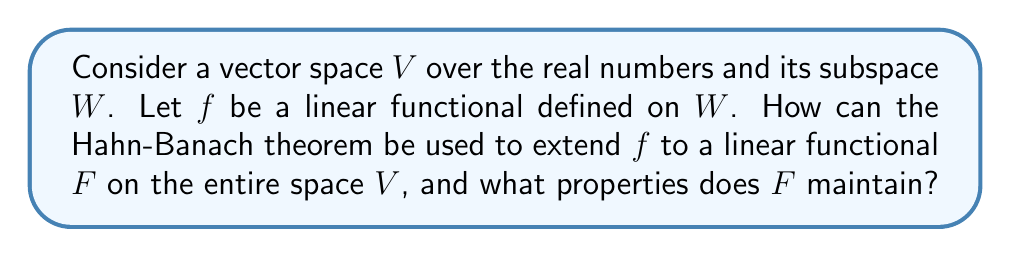Can you answer this question? To understand how the Hahn-Banach theorem applies in this situation, let's break it down step-by-step:

1) First, recall the Hahn-Banach theorem: Let $W$ be a subspace of a real vector space $V$, and let $f$ be a linear functional on $W$. If $p$ is a sublinear functional on $V$ such that $f(w) \leq p(w)$ for all $w \in W$, then there exists a linear functional $F$ on $V$ that extends $f$ (i.e., $F|_W = f$) and satisfies $F(v) \leq p(v)$ for all $v \in V$.

2) In our case, we need to define a suitable sublinear functional $p$ on $V$. A natural choice is:

   $$p(v) = \inf\{|f(w)| + \|v-w\| : w \in W\}$$

   where $\|\cdot\|$ is a norm on $V$.

3) We need to verify that $p$ is indeed sublinear and dominates $f$ on $W$:
   
   a) $p(v_1 + v_2) \leq p(v_1) + p(v_2)$ (subadditivity)
   b) $p(\alpha v) = |\alpha| p(v)$ for all scalars $\alpha$ (positive homogeneity)
   c) $f(w) \leq p(w)$ for all $w \in W$

4) Once we've verified these conditions, we can apply the Hahn-Banach theorem to extend $f$ to a linear functional $F$ on all of $V$.

5) The extended functional $F$ will have the following properties:

   a) $F|_W = f$ (extension property)
   b) $F(v) \leq p(v)$ for all $v \in V$ (domination by $p$)
   c) $\|F\| = \|f\|$ (norm-preserving)

The last property follows from the definition of $p$ and the fact that $F$ is an extension of $f$.
Answer: The Hahn-Banach theorem can be used to extend the linear functional $f$ from $W$ to a linear functional $F$ on the entire space $V$ by defining a suitable sublinear functional $p$ on $V$ that dominates $f$ on $W$. The extended functional $F$ will satisfy:

1) $F|_W = f$ (extension property)
2) $F(v) \leq p(v)$ for all $v \in V$ (domination by $p$)
3) $\|F\| = \|f\|$ (norm-preserving) 